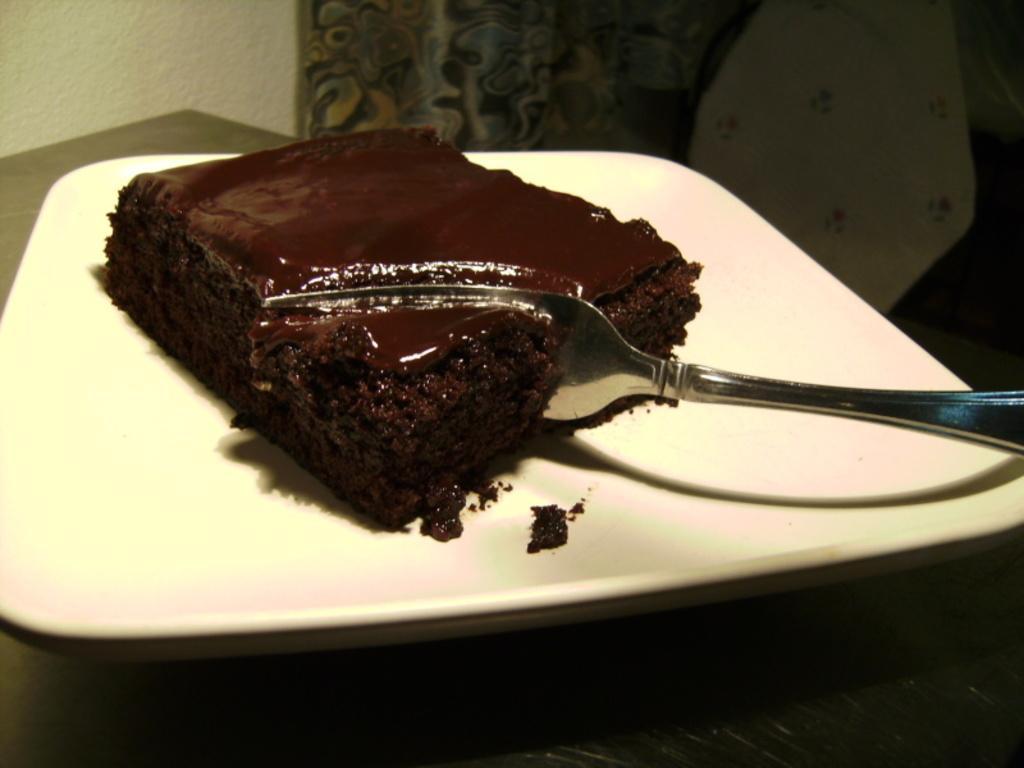In one or two sentences, can you explain what this image depicts? In this image at the bottom there is one table, on the table there is one plate. And in the plate there is one cake and spoon and in the background there is wall, curtain and some cloth. 